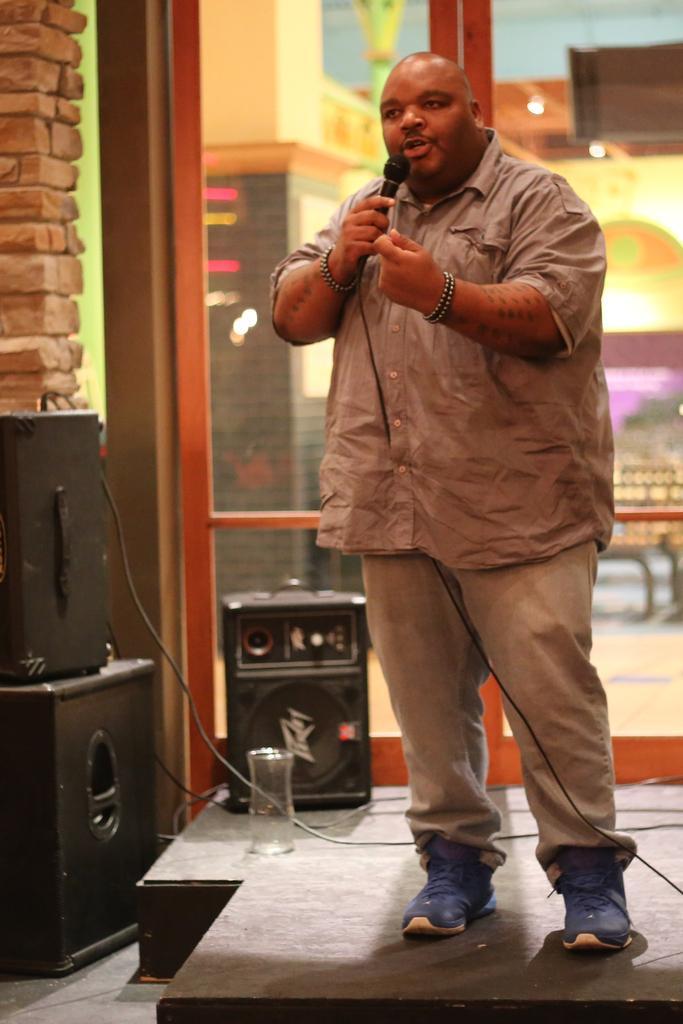Describe this image in one or two sentences. In this image I see a man who is holding a mic and standing on the stage. In the background I see the speakers, wall and the window. 